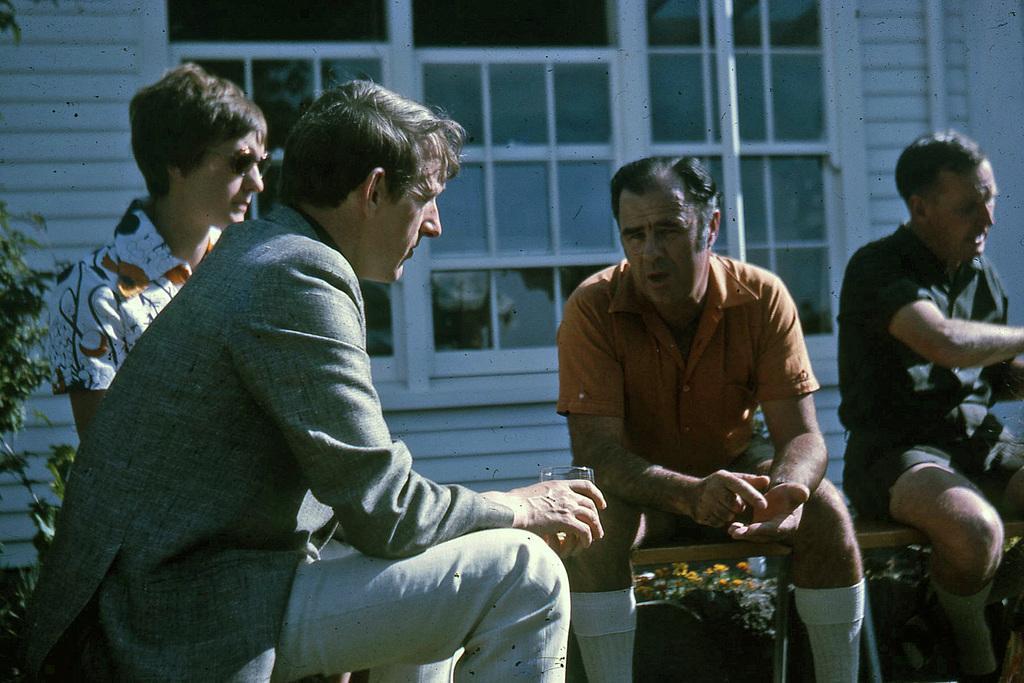Can you describe this image briefly? In the picture I can see few persons sitting where one among them is holding a glass in their hands and there is a glass window behind them and there is a plant in the left corner. 